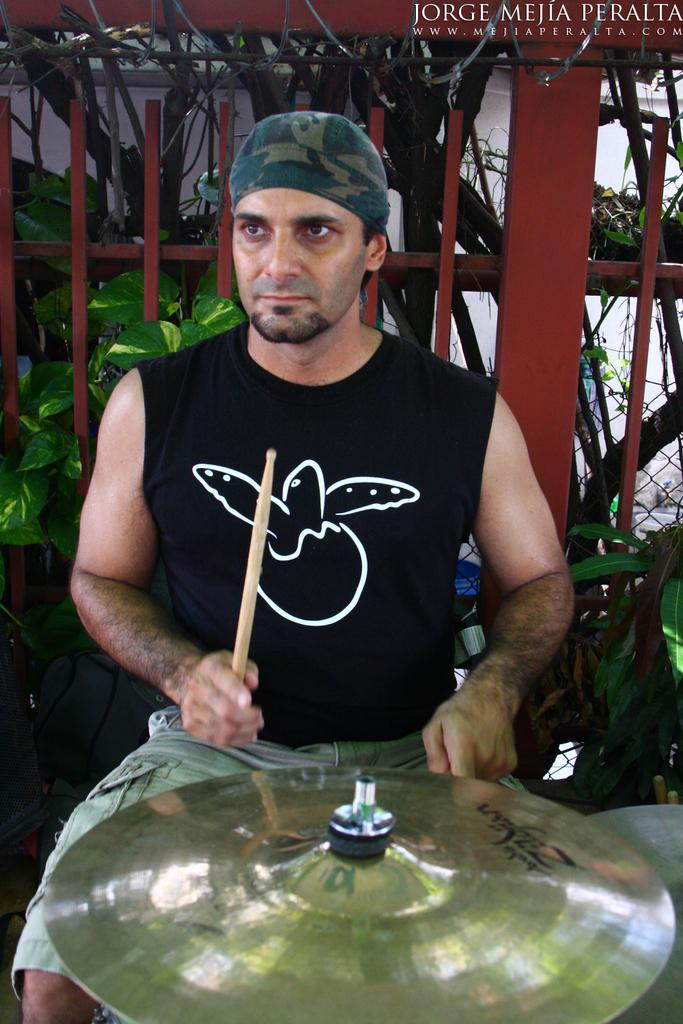What is the person in the image doing? The person is sitting in the image. What object is the person holding? The person is holding a stick. What is in front of the person? There is a musical instrument in front of the person. What can be seen in the background of the image? There are plants, a fence, and a wall in the background of the image. What type of dirt can be seen on the musical instrument in the image? There is no dirt visible on the musical instrument in the image. 